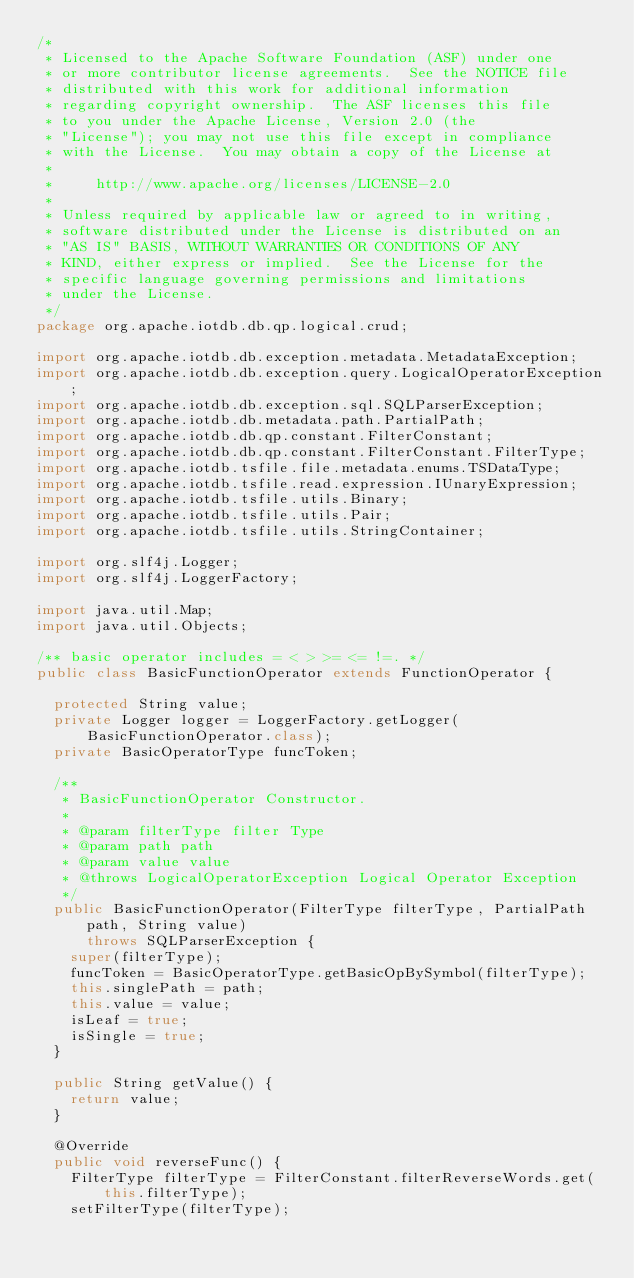<code> <loc_0><loc_0><loc_500><loc_500><_Java_>/*
 * Licensed to the Apache Software Foundation (ASF) under one
 * or more contributor license agreements.  See the NOTICE file
 * distributed with this work for additional information
 * regarding copyright ownership.  The ASF licenses this file
 * to you under the Apache License, Version 2.0 (the
 * "License"); you may not use this file except in compliance
 * with the License.  You may obtain a copy of the License at
 *
 *     http://www.apache.org/licenses/LICENSE-2.0
 *
 * Unless required by applicable law or agreed to in writing,
 * software distributed under the License is distributed on an
 * "AS IS" BASIS, WITHOUT WARRANTIES OR CONDITIONS OF ANY
 * KIND, either express or implied.  See the License for the
 * specific language governing permissions and limitations
 * under the License.
 */
package org.apache.iotdb.db.qp.logical.crud;

import org.apache.iotdb.db.exception.metadata.MetadataException;
import org.apache.iotdb.db.exception.query.LogicalOperatorException;
import org.apache.iotdb.db.exception.sql.SQLParserException;
import org.apache.iotdb.db.metadata.path.PartialPath;
import org.apache.iotdb.db.qp.constant.FilterConstant;
import org.apache.iotdb.db.qp.constant.FilterConstant.FilterType;
import org.apache.iotdb.tsfile.file.metadata.enums.TSDataType;
import org.apache.iotdb.tsfile.read.expression.IUnaryExpression;
import org.apache.iotdb.tsfile.utils.Binary;
import org.apache.iotdb.tsfile.utils.Pair;
import org.apache.iotdb.tsfile.utils.StringContainer;

import org.slf4j.Logger;
import org.slf4j.LoggerFactory;

import java.util.Map;
import java.util.Objects;

/** basic operator includes = < > >= <= !=. */
public class BasicFunctionOperator extends FunctionOperator {

  protected String value;
  private Logger logger = LoggerFactory.getLogger(BasicFunctionOperator.class);
  private BasicOperatorType funcToken;

  /**
   * BasicFunctionOperator Constructor.
   *
   * @param filterType filter Type
   * @param path path
   * @param value value
   * @throws LogicalOperatorException Logical Operator Exception
   */
  public BasicFunctionOperator(FilterType filterType, PartialPath path, String value)
      throws SQLParserException {
    super(filterType);
    funcToken = BasicOperatorType.getBasicOpBySymbol(filterType);
    this.singlePath = path;
    this.value = value;
    isLeaf = true;
    isSingle = true;
  }

  public String getValue() {
    return value;
  }

  @Override
  public void reverseFunc() {
    FilterType filterType = FilterConstant.filterReverseWords.get(this.filterType);
    setFilterType(filterType);</code> 